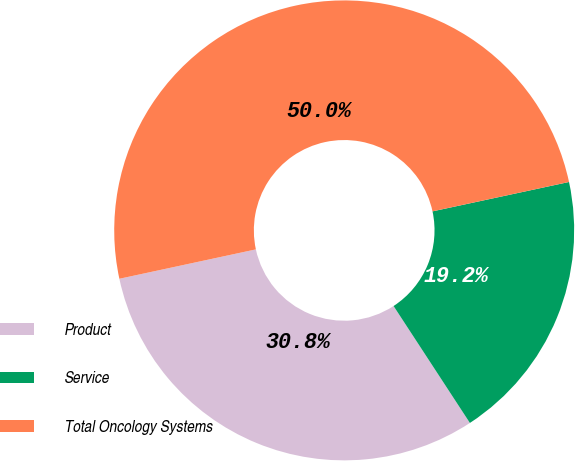Convert chart. <chart><loc_0><loc_0><loc_500><loc_500><pie_chart><fcel>Product<fcel>Service<fcel>Total Oncology Systems<nl><fcel>30.83%<fcel>19.17%<fcel>50.0%<nl></chart> 